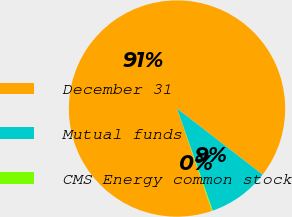Convert chart to OTSL. <chart><loc_0><loc_0><loc_500><loc_500><pie_chart><fcel>December 31<fcel>Mutual funds<fcel>CMS Energy common stock<nl><fcel>90.68%<fcel>9.19%<fcel>0.13%<nl></chart> 